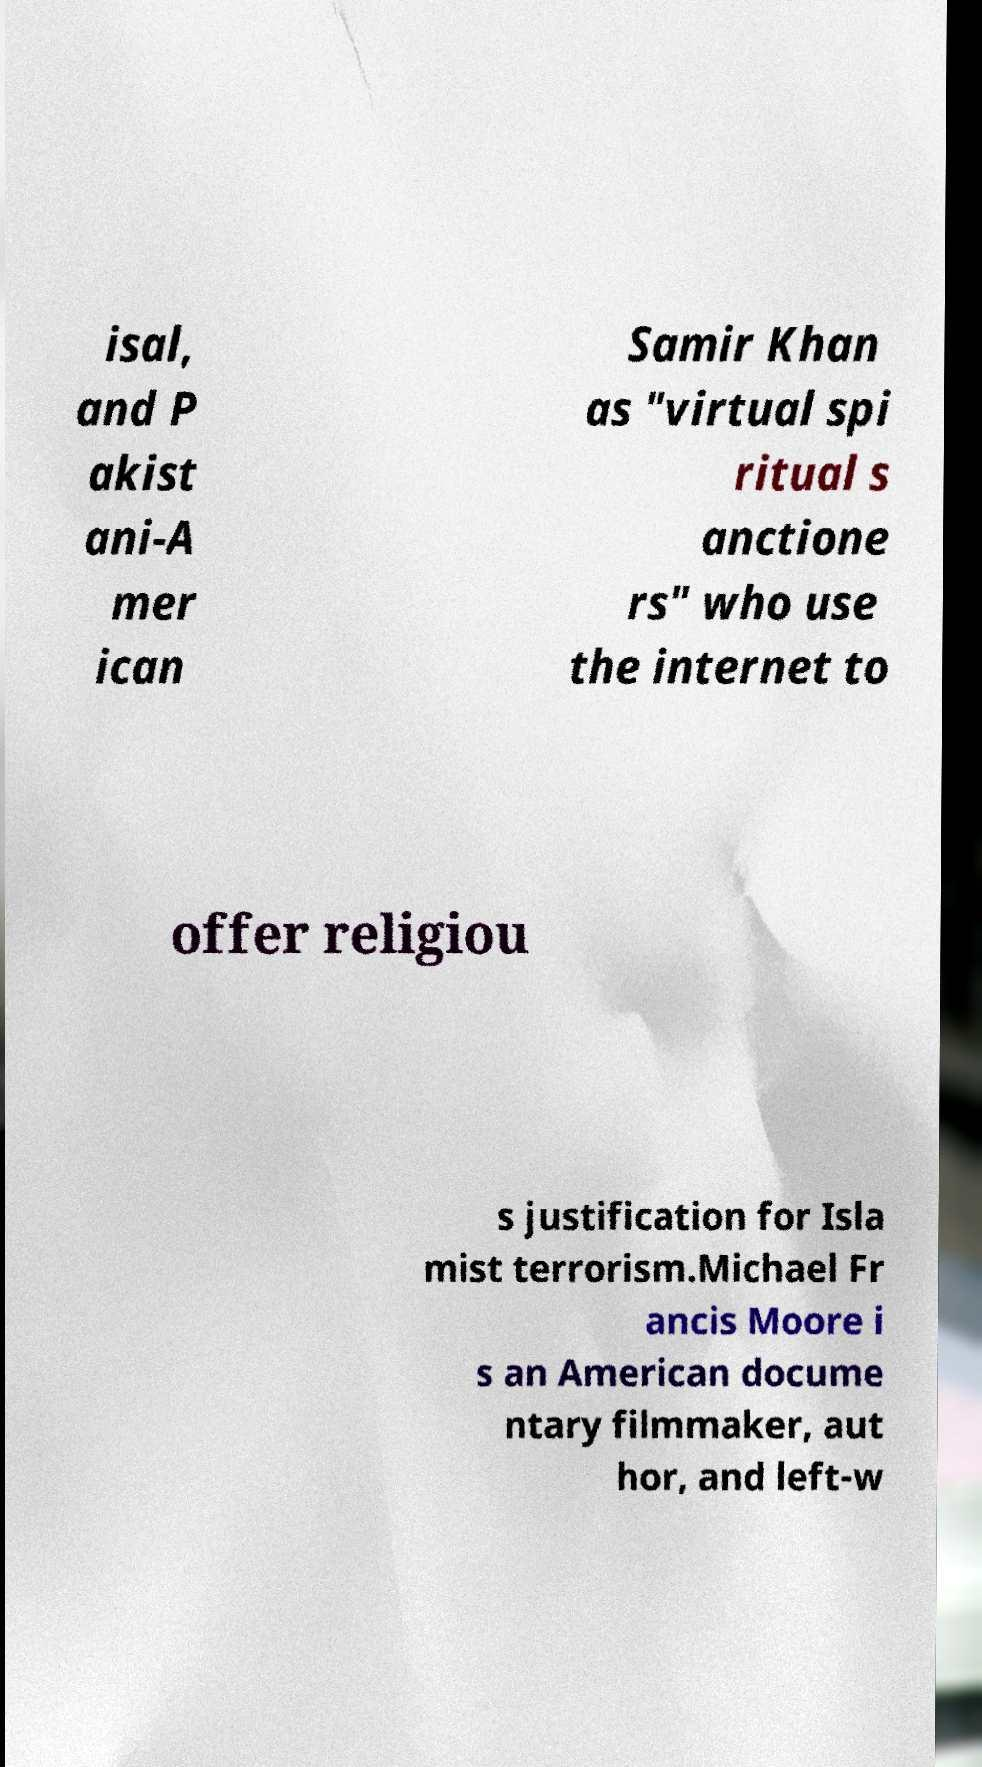Can you accurately transcribe the text from the provided image for me? isal, and P akist ani-A mer ican Samir Khan as "virtual spi ritual s anctione rs" who use the internet to offer religiou s justification for Isla mist terrorism.Michael Fr ancis Moore i s an American docume ntary filmmaker, aut hor, and left-w 